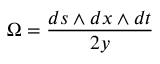Convert formula to latex. <formula><loc_0><loc_0><loc_500><loc_500>\Omega = \frac { d s \wedge d x \wedge d t } { 2 y }</formula> 